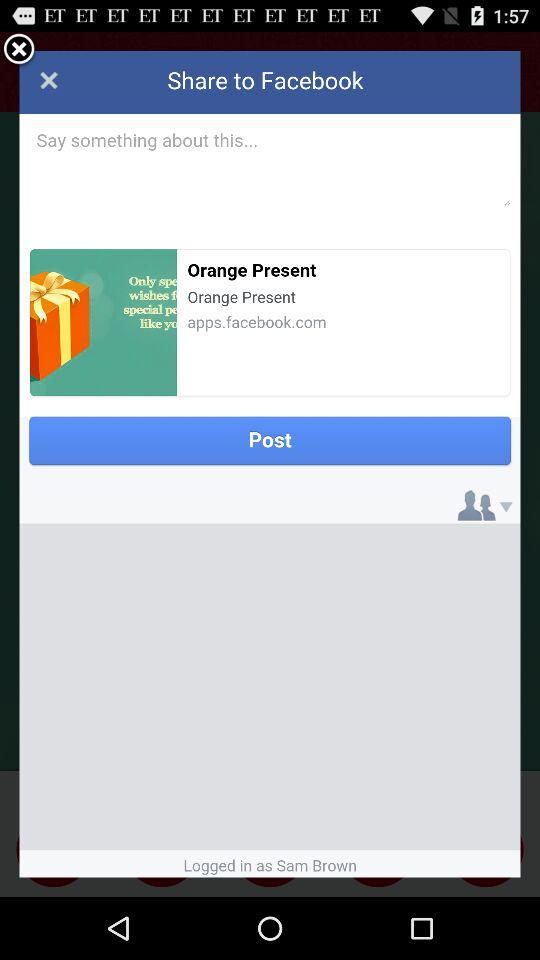On what application can I share? You can share on "Facebook". 